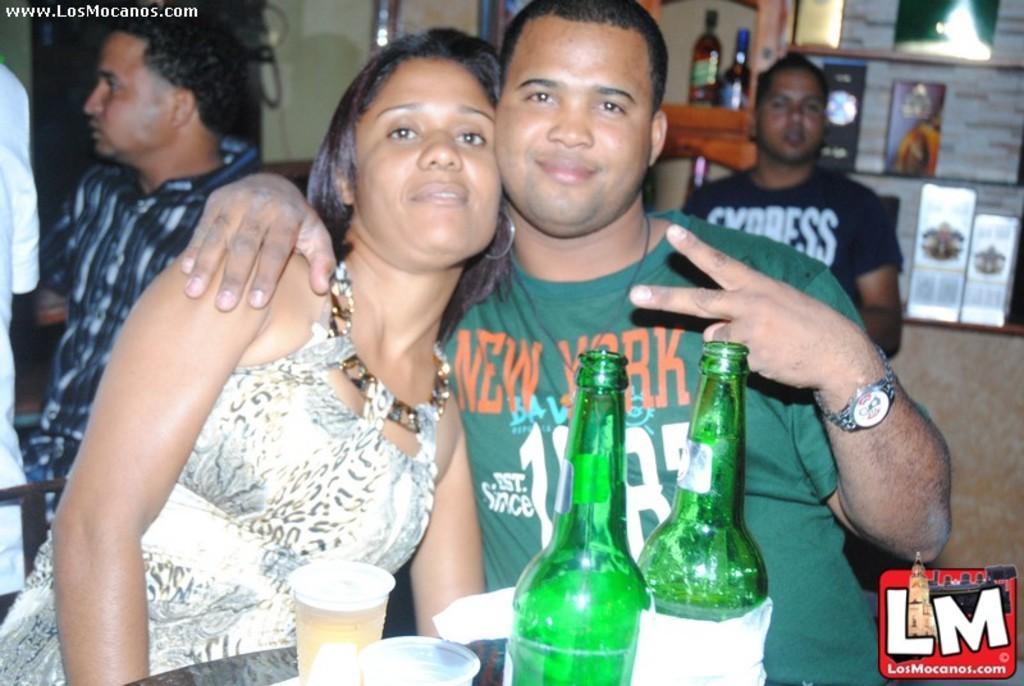Describe this image in one or two sentences. In this image ii can see a woman and a man sitting at the front i can see two bottles, a glass on the table at the back ground i can see two men sitting, few boards and two bottles. 